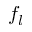<formula> <loc_0><loc_0><loc_500><loc_500>f _ { l }</formula> 